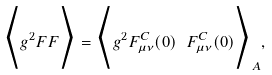Convert formula to latex. <formula><loc_0><loc_0><loc_500><loc_500>\Big < g ^ { 2 } F F \Big > = \Big < g ^ { 2 } F _ { \mu \nu } ^ { C } ( 0 ) \ F _ { \mu \nu } ^ { C } ( 0 ) \Big > _ { A } ,</formula> 